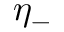<formula> <loc_0><loc_0><loc_500><loc_500>\eta _ { - }</formula> 